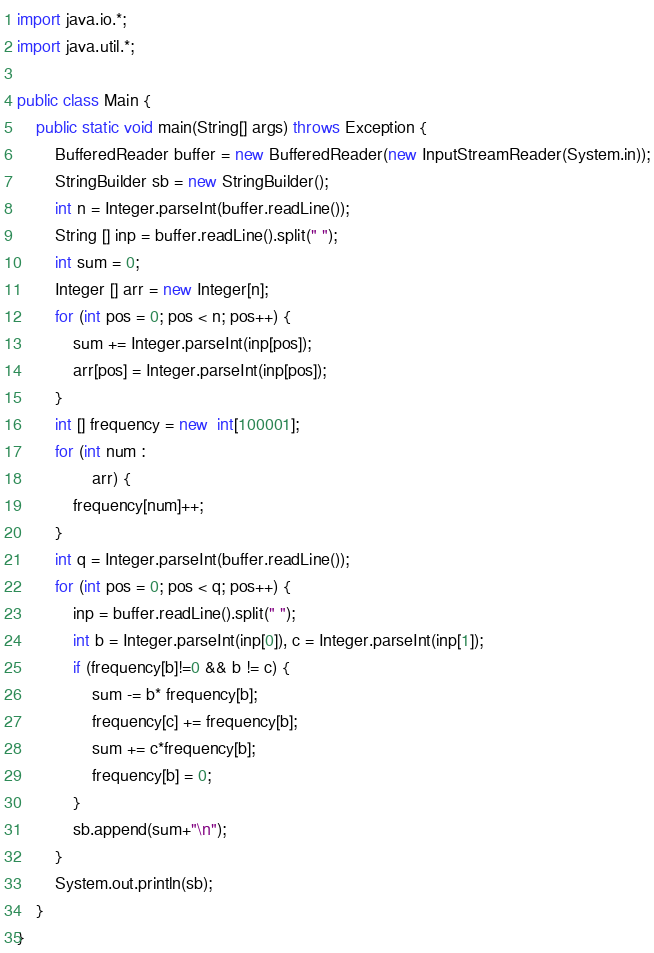Convert code to text. <code><loc_0><loc_0><loc_500><loc_500><_Java_>import java.io.*;
import java.util.*;

public class Main {
    public static void main(String[] args) throws Exception {
        BufferedReader buffer = new BufferedReader(new InputStreamReader(System.in));
        StringBuilder sb = new StringBuilder();
        int n = Integer.parseInt(buffer.readLine());
        String [] inp = buffer.readLine().split(" ");
        int sum = 0;
        Integer [] arr = new Integer[n];
        for (int pos = 0; pos < n; pos++) {
            sum += Integer.parseInt(inp[pos]);
            arr[pos] = Integer.parseInt(inp[pos]);
        }
        int [] frequency = new  int[100001];
        for (int num :
                arr) {
            frequency[num]++;
        }
        int q = Integer.parseInt(buffer.readLine());
        for (int pos = 0; pos < q; pos++) {
            inp = buffer.readLine().split(" ");
            int b = Integer.parseInt(inp[0]), c = Integer.parseInt(inp[1]);
            if (frequency[b]!=0 && b != c) {
                sum -= b* frequency[b];
                frequency[c] += frequency[b];
                sum += c*frequency[b];
                frequency[b] = 0;
            }
            sb.append(sum+"\n");
        }
        System.out.println(sb);
    }
}
</code> 